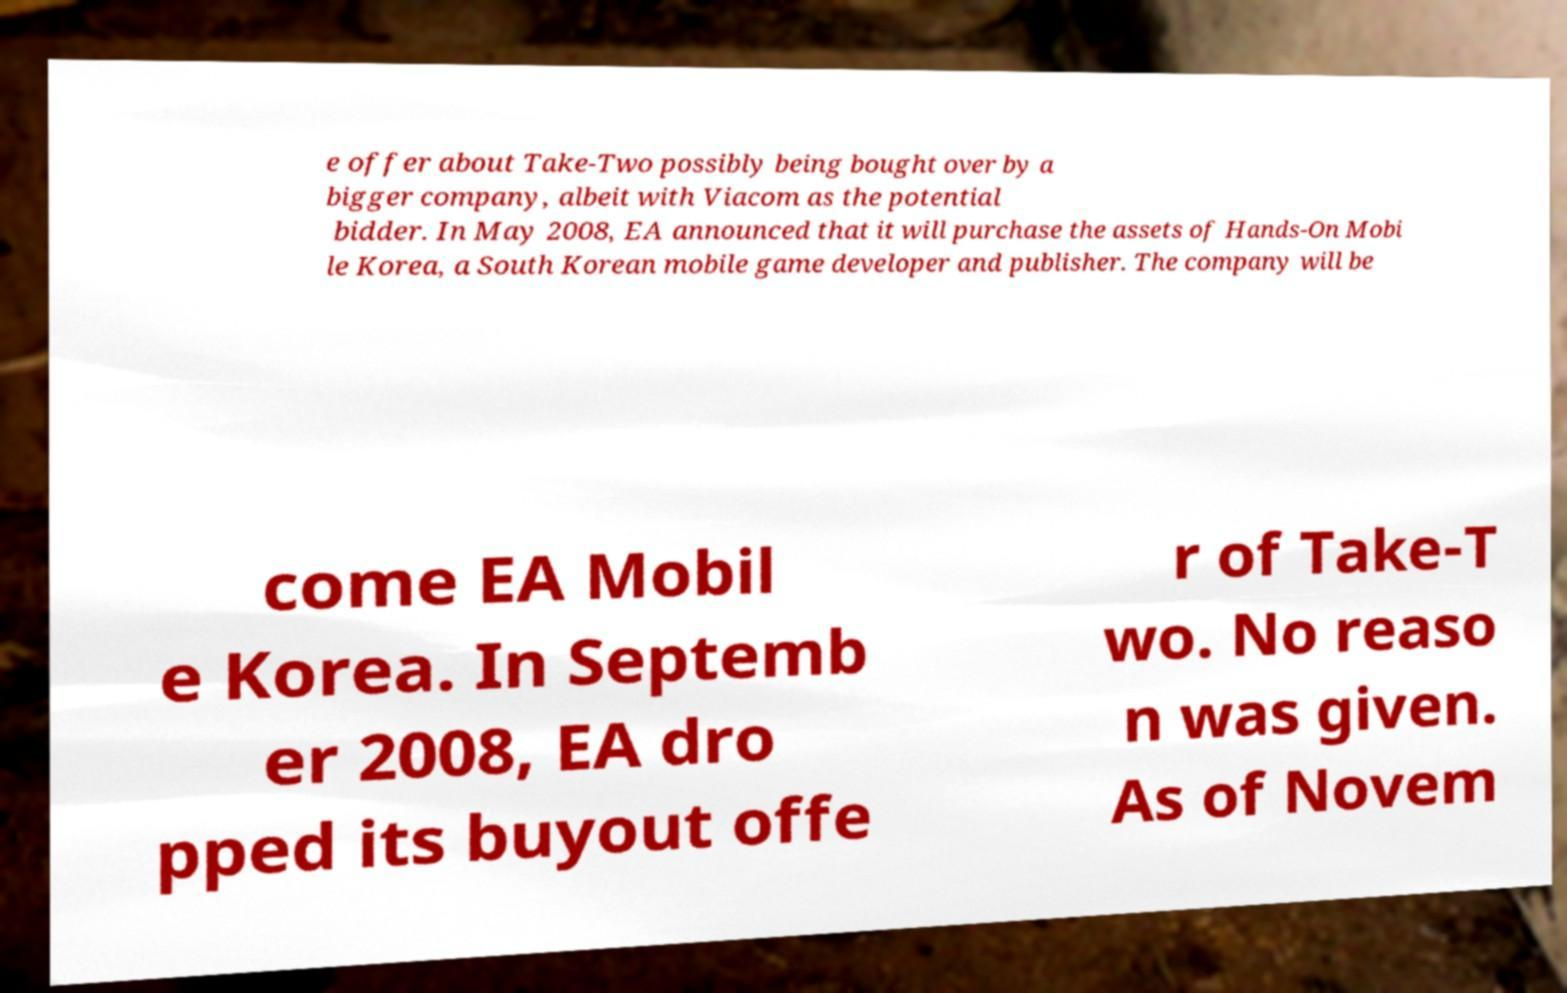Could you extract and type out the text from this image? e offer about Take-Two possibly being bought over by a bigger company, albeit with Viacom as the potential bidder. In May 2008, EA announced that it will purchase the assets of Hands-On Mobi le Korea, a South Korean mobile game developer and publisher. The company will be come EA Mobil e Korea. In Septemb er 2008, EA dro pped its buyout offe r of Take-T wo. No reaso n was given. As of Novem 